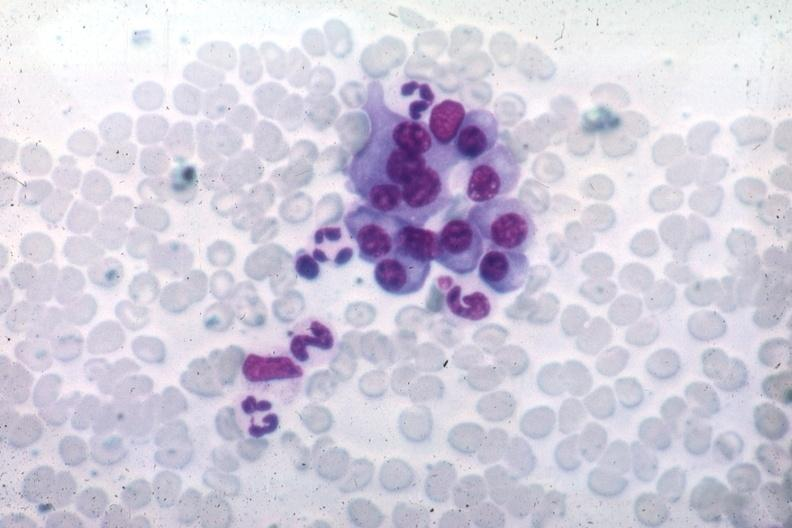what is present?
Answer the question using a single word or phrase. Hematologic 